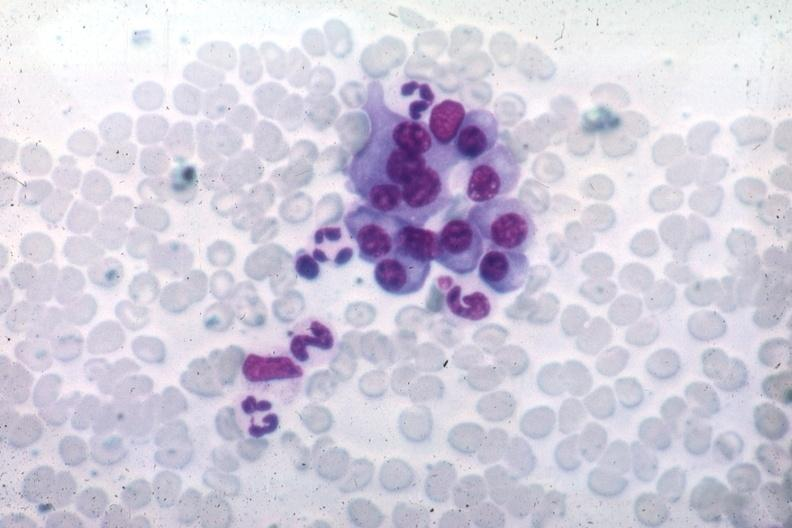what is present?
Answer the question using a single word or phrase. Hematologic 